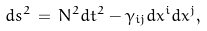<formula> <loc_0><loc_0><loc_500><loc_500>d s ^ { 2 } \, = \, N ^ { 2 } d t ^ { 2 } - \gamma _ { i j } d x ^ { i } d x ^ { j } ,</formula> 